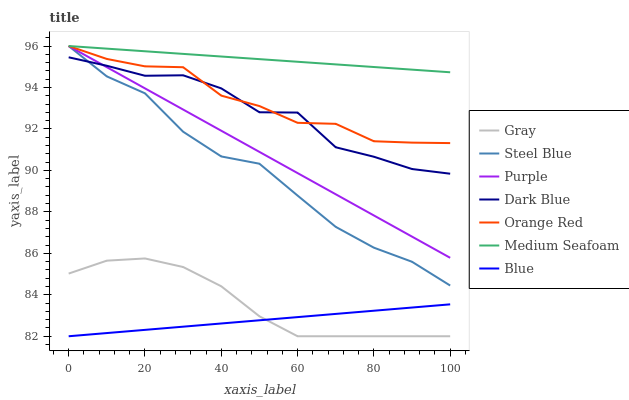Does Blue have the minimum area under the curve?
Answer yes or no. Yes. Does Medium Seafoam have the maximum area under the curve?
Answer yes or no. Yes. Does Gray have the minimum area under the curve?
Answer yes or no. No. Does Gray have the maximum area under the curve?
Answer yes or no. No. Is Purple the smoothest?
Answer yes or no. Yes. Is Dark Blue the roughest?
Answer yes or no. Yes. Is Gray the smoothest?
Answer yes or no. No. Is Gray the roughest?
Answer yes or no. No. Does Blue have the lowest value?
Answer yes or no. Yes. Does Purple have the lowest value?
Answer yes or no. No. Does Medium Seafoam have the highest value?
Answer yes or no. Yes. Does Gray have the highest value?
Answer yes or no. No. Is Blue less than Orange Red?
Answer yes or no. Yes. Is Steel Blue greater than Gray?
Answer yes or no. Yes. Does Steel Blue intersect Dark Blue?
Answer yes or no. Yes. Is Steel Blue less than Dark Blue?
Answer yes or no. No. Is Steel Blue greater than Dark Blue?
Answer yes or no. No. Does Blue intersect Orange Red?
Answer yes or no. No. 